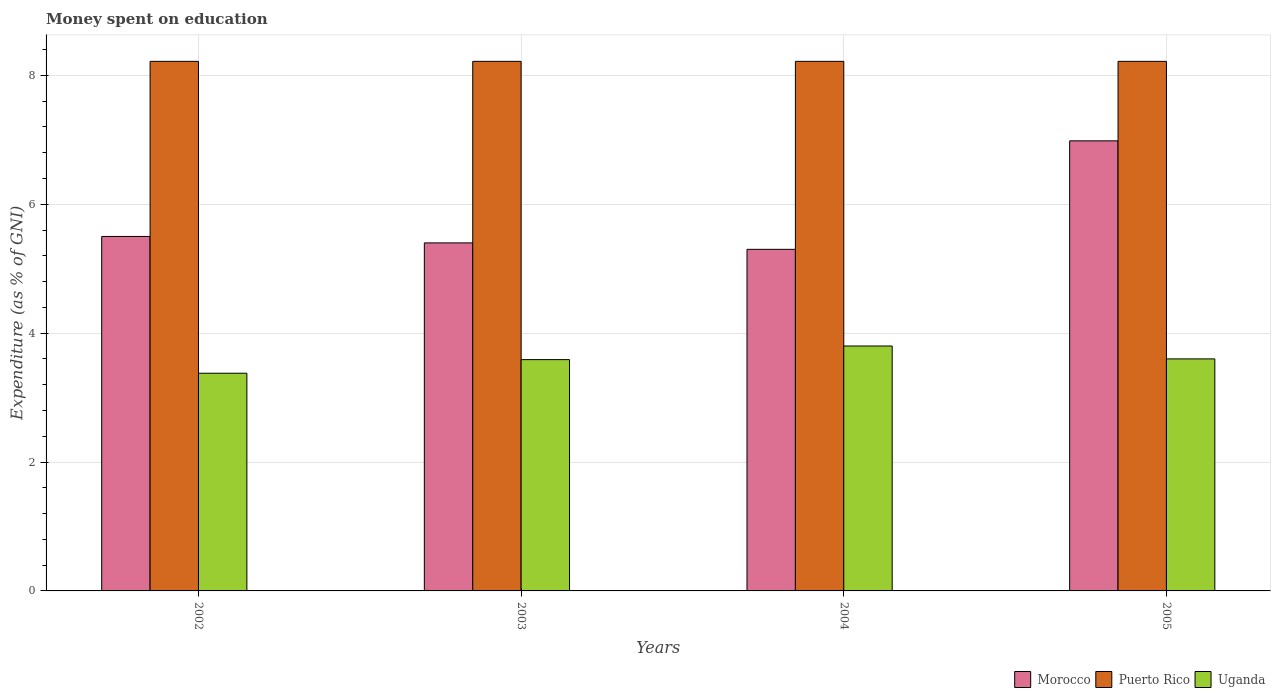How many different coloured bars are there?
Make the answer very short. 3. Are the number of bars per tick equal to the number of legend labels?
Make the answer very short. Yes. What is the amount of money spent on education in Morocco in 2002?
Give a very brief answer. 5.5. Across all years, what is the maximum amount of money spent on education in Morocco?
Give a very brief answer. 6.98. Across all years, what is the minimum amount of money spent on education in Uganda?
Provide a short and direct response. 3.38. What is the total amount of money spent on education in Uganda in the graph?
Provide a succinct answer. 14.37. What is the difference between the amount of money spent on education in Morocco in 2003 and that in 2005?
Provide a short and direct response. -1.58. What is the difference between the amount of money spent on education in Puerto Rico in 2005 and the amount of money spent on education in Morocco in 2003?
Ensure brevity in your answer.  2.82. What is the average amount of money spent on education in Uganda per year?
Provide a succinct answer. 3.59. In the year 2002, what is the difference between the amount of money spent on education in Puerto Rico and amount of money spent on education in Uganda?
Offer a very short reply. 4.84. What is the ratio of the amount of money spent on education in Morocco in 2004 to that in 2005?
Your response must be concise. 0.76. What is the difference between the highest and the second highest amount of money spent on education in Morocco?
Your response must be concise. 1.48. What is the difference between the highest and the lowest amount of money spent on education in Morocco?
Provide a short and direct response. 1.68. In how many years, is the amount of money spent on education in Uganda greater than the average amount of money spent on education in Uganda taken over all years?
Make the answer very short. 2. What does the 2nd bar from the left in 2003 represents?
Provide a short and direct response. Puerto Rico. What does the 3rd bar from the right in 2003 represents?
Make the answer very short. Morocco. Is it the case that in every year, the sum of the amount of money spent on education in Uganda and amount of money spent on education in Morocco is greater than the amount of money spent on education in Puerto Rico?
Your answer should be very brief. Yes. How many years are there in the graph?
Make the answer very short. 4. Where does the legend appear in the graph?
Your answer should be compact. Bottom right. How are the legend labels stacked?
Make the answer very short. Horizontal. What is the title of the graph?
Your answer should be very brief. Money spent on education. What is the label or title of the Y-axis?
Give a very brief answer. Expenditure (as % of GNI). What is the Expenditure (as % of GNI) of Morocco in 2002?
Provide a short and direct response. 5.5. What is the Expenditure (as % of GNI) of Puerto Rico in 2002?
Ensure brevity in your answer.  8.22. What is the Expenditure (as % of GNI) of Uganda in 2002?
Keep it short and to the point. 3.38. What is the Expenditure (as % of GNI) in Morocco in 2003?
Your response must be concise. 5.4. What is the Expenditure (as % of GNI) of Puerto Rico in 2003?
Provide a succinct answer. 8.22. What is the Expenditure (as % of GNI) of Uganda in 2003?
Ensure brevity in your answer.  3.59. What is the Expenditure (as % of GNI) of Morocco in 2004?
Your answer should be very brief. 5.3. What is the Expenditure (as % of GNI) of Puerto Rico in 2004?
Provide a short and direct response. 8.22. What is the Expenditure (as % of GNI) in Morocco in 2005?
Your answer should be compact. 6.98. What is the Expenditure (as % of GNI) in Puerto Rico in 2005?
Offer a very short reply. 8.22. What is the Expenditure (as % of GNI) in Uganda in 2005?
Provide a succinct answer. 3.6. Across all years, what is the maximum Expenditure (as % of GNI) in Morocco?
Your response must be concise. 6.98. Across all years, what is the maximum Expenditure (as % of GNI) in Puerto Rico?
Give a very brief answer. 8.22. Across all years, what is the maximum Expenditure (as % of GNI) of Uganda?
Provide a short and direct response. 3.8. Across all years, what is the minimum Expenditure (as % of GNI) in Morocco?
Offer a terse response. 5.3. Across all years, what is the minimum Expenditure (as % of GNI) of Puerto Rico?
Provide a short and direct response. 8.22. Across all years, what is the minimum Expenditure (as % of GNI) in Uganda?
Your answer should be very brief. 3.38. What is the total Expenditure (as % of GNI) in Morocco in the graph?
Give a very brief answer. 23.18. What is the total Expenditure (as % of GNI) of Puerto Rico in the graph?
Offer a very short reply. 32.87. What is the total Expenditure (as % of GNI) in Uganda in the graph?
Offer a terse response. 14.37. What is the difference between the Expenditure (as % of GNI) in Uganda in 2002 and that in 2003?
Make the answer very short. -0.21. What is the difference between the Expenditure (as % of GNI) of Uganda in 2002 and that in 2004?
Your answer should be compact. -0.42. What is the difference between the Expenditure (as % of GNI) in Morocco in 2002 and that in 2005?
Offer a terse response. -1.48. What is the difference between the Expenditure (as % of GNI) of Puerto Rico in 2002 and that in 2005?
Offer a terse response. 0. What is the difference between the Expenditure (as % of GNI) of Uganda in 2002 and that in 2005?
Offer a very short reply. -0.22. What is the difference between the Expenditure (as % of GNI) in Uganda in 2003 and that in 2004?
Offer a terse response. -0.21. What is the difference between the Expenditure (as % of GNI) in Morocco in 2003 and that in 2005?
Your response must be concise. -1.58. What is the difference between the Expenditure (as % of GNI) of Uganda in 2003 and that in 2005?
Your answer should be compact. -0.01. What is the difference between the Expenditure (as % of GNI) of Morocco in 2004 and that in 2005?
Keep it short and to the point. -1.68. What is the difference between the Expenditure (as % of GNI) in Morocco in 2002 and the Expenditure (as % of GNI) in Puerto Rico in 2003?
Provide a short and direct response. -2.72. What is the difference between the Expenditure (as % of GNI) in Morocco in 2002 and the Expenditure (as % of GNI) in Uganda in 2003?
Make the answer very short. 1.91. What is the difference between the Expenditure (as % of GNI) in Puerto Rico in 2002 and the Expenditure (as % of GNI) in Uganda in 2003?
Give a very brief answer. 4.63. What is the difference between the Expenditure (as % of GNI) in Morocco in 2002 and the Expenditure (as % of GNI) in Puerto Rico in 2004?
Your response must be concise. -2.72. What is the difference between the Expenditure (as % of GNI) in Morocco in 2002 and the Expenditure (as % of GNI) in Uganda in 2004?
Your answer should be very brief. 1.7. What is the difference between the Expenditure (as % of GNI) in Puerto Rico in 2002 and the Expenditure (as % of GNI) in Uganda in 2004?
Provide a succinct answer. 4.42. What is the difference between the Expenditure (as % of GNI) of Morocco in 2002 and the Expenditure (as % of GNI) of Puerto Rico in 2005?
Offer a terse response. -2.72. What is the difference between the Expenditure (as % of GNI) in Puerto Rico in 2002 and the Expenditure (as % of GNI) in Uganda in 2005?
Your answer should be very brief. 4.62. What is the difference between the Expenditure (as % of GNI) in Morocco in 2003 and the Expenditure (as % of GNI) in Puerto Rico in 2004?
Keep it short and to the point. -2.82. What is the difference between the Expenditure (as % of GNI) of Puerto Rico in 2003 and the Expenditure (as % of GNI) of Uganda in 2004?
Provide a succinct answer. 4.42. What is the difference between the Expenditure (as % of GNI) of Morocco in 2003 and the Expenditure (as % of GNI) of Puerto Rico in 2005?
Offer a very short reply. -2.82. What is the difference between the Expenditure (as % of GNI) in Puerto Rico in 2003 and the Expenditure (as % of GNI) in Uganda in 2005?
Provide a succinct answer. 4.62. What is the difference between the Expenditure (as % of GNI) in Morocco in 2004 and the Expenditure (as % of GNI) in Puerto Rico in 2005?
Your answer should be compact. -2.92. What is the difference between the Expenditure (as % of GNI) in Puerto Rico in 2004 and the Expenditure (as % of GNI) in Uganda in 2005?
Give a very brief answer. 4.62. What is the average Expenditure (as % of GNI) of Morocco per year?
Ensure brevity in your answer.  5.8. What is the average Expenditure (as % of GNI) in Puerto Rico per year?
Offer a terse response. 8.22. What is the average Expenditure (as % of GNI) in Uganda per year?
Keep it short and to the point. 3.59. In the year 2002, what is the difference between the Expenditure (as % of GNI) in Morocco and Expenditure (as % of GNI) in Puerto Rico?
Give a very brief answer. -2.72. In the year 2002, what is the difference between the Expenditure (as % of GNI) of Morocco and Expenditure (as % of GNI) of Uganda?
Offer a very short reply. 2.12. In the year 2002, what is the difference between the Expenditure (as % of GNI) of Puerto Rico and Expenditure (as % of GNI) of Uganda?
Your response must be concise. 4.84. In the year 2003, what is the difference between the Expenditure (as % of GNI) in Morocco and Expenditure (as % of GNI) in Puerto Rico?
Keep it short and to the point. -2.82. In the year 2003, what is the difference between the Expenditure (as % of GNI) in Morocco and Expenditure (as % of GNI) in Uganda?
Give a very brief answer. 1.81. In the year 2003, what is the difference between the Expenditure (as % of GNI) of Puerto Rico and Expenditure (as % of GNI) of Uganda?
Make the answer very short. 4.63. In the year 2004, what is the difference between the Expenditure (as % of GNI) of Morocco and Expenditure (as % of GNI) of Puerto Rico?
Your answer should be compact. -2.92. In the year 2004, what is the difference between the Expenditure (as % of GNI) in Morocco and Expenditure (as % of GNI) in Uganda?
Provide a succinct answer. 1.5. In the year 2004, what is the difference between the Expenditure (as % of GNI) of Puerto Rico and Expenditure (as % of GNI) of Uganda?
Your answer should be very brief. 4.42. In the year 2005, what is the difference between the Expenditure (as % of GNI) in Morocco and Expenditure (as % of GNI) in Puerto Rico?
Your answer should be compact. -1.23. In the year 2005, what is the difference between the Expenditure (as % of GNI) in Morocco and Expenditure (as % of GNI) in Uganda?
Keep it short and to the point. 3.38. In the year 2005, what is the difference between the Expenditure (as % of GNI) in Puerto Rico and Expenditure (as % of GNI) in Uganda?
Provide a short and direct response. 4.62. What is the ratio of the Expenditure (as % of GNI) in Morocco in 2002 to that in 2003?
Give a very brief answer. 1.02. What is the ratio of the Expenditure (as % of GNI) in Uganda in 2002 to that in 2003?
Your answer should be very brief. 0.94. What is the ratio of the Expenditure (as % of GNI) in Morocco in 2002 to that in 2004?
Give a very brief answer. 1.04. What is the ratio of the Expenditure (as % of GNI) in Uganda in 2002 to that in 2004?
Ensure brevity in your answer.  0.89. What is the ratio of the Expenditure (as % of GNI) of Morocco in 2002 to that in 2005?
Provide a short and direct response. 0.79. What is the ratio of the Expenditure (as % of GNI) of Uganda in 2002 to that in 2005?
Your answer should be very brief. 0.94. What is the ratio of the Expenditure (as % of GNI) in Morocco in 2003 to that in 2004?
Your answer should be very brief. 1.02. What is the ratio of the Expenditure (as % of GNI) in Puerto Rico in 2003 to that in 2004?
Give a very brief answer. 1. What is the ratio of the Expenditure (as % of GNI) in Morocco in 2003 to that in 2005?
Offer a terse response. 0.77. What is the ratio of the Expenditure (as % of GNI) in Puerto Rico in 2003 to that in 2005?
Offer a very short reply. 1. What is the ratio of the Expenditure (as % of GNI) in Morocco in 2004 to that in 2005?
Provide a succinct answer. 0.76. What is the ratio of the Expenditure (as % of GNI) of Puerto Rico in 2004 to that in 2005?
Give a very brief answer. 1. What is the ratio of the Expenditure (as % of GNI) of Uganda in 2004 to that in 2005?
Offer a terse response. 1.06. What is the difference between the highest and the second highest Expenditure (as % of GNI) in Morocco?
Provide a succinct answer. 1.48. What is the difference between the highest and the second highest Expenditure (as % of GNI) in Puerto Rico?
Ensure brevity in your answer.  0. What is the difference between the highest and the lowest Expenditure (as % of GNI) in Morocco?
Provide a short and direct response. 1.68. What is the difference between the highest and the lowest Expenditure (as % of GNI) of Puerto Rico?
Your response must be concise. 0. What is the difference between the highest and the lowest Expenditure (as % of GNI) in Uganda?
Give a very brief answer. 0.42. 